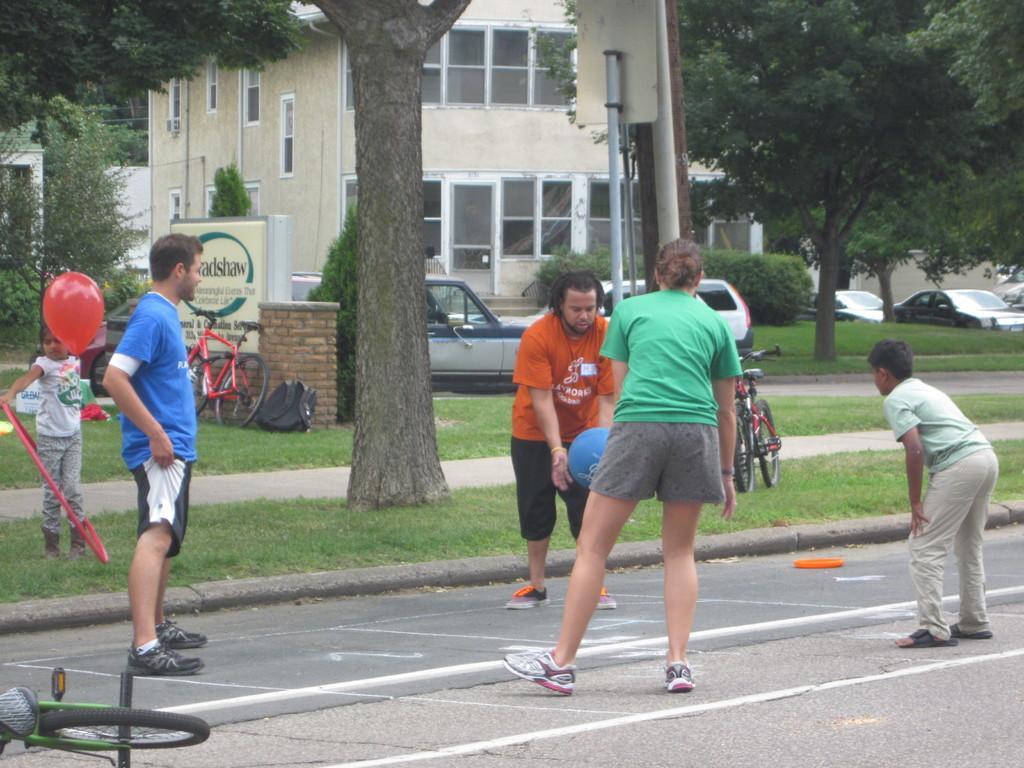Describe this image in one or two sentences. In this image, we can see some people playing a game, there are some bicycles and cars, there are some green color trees, we can see a building. 